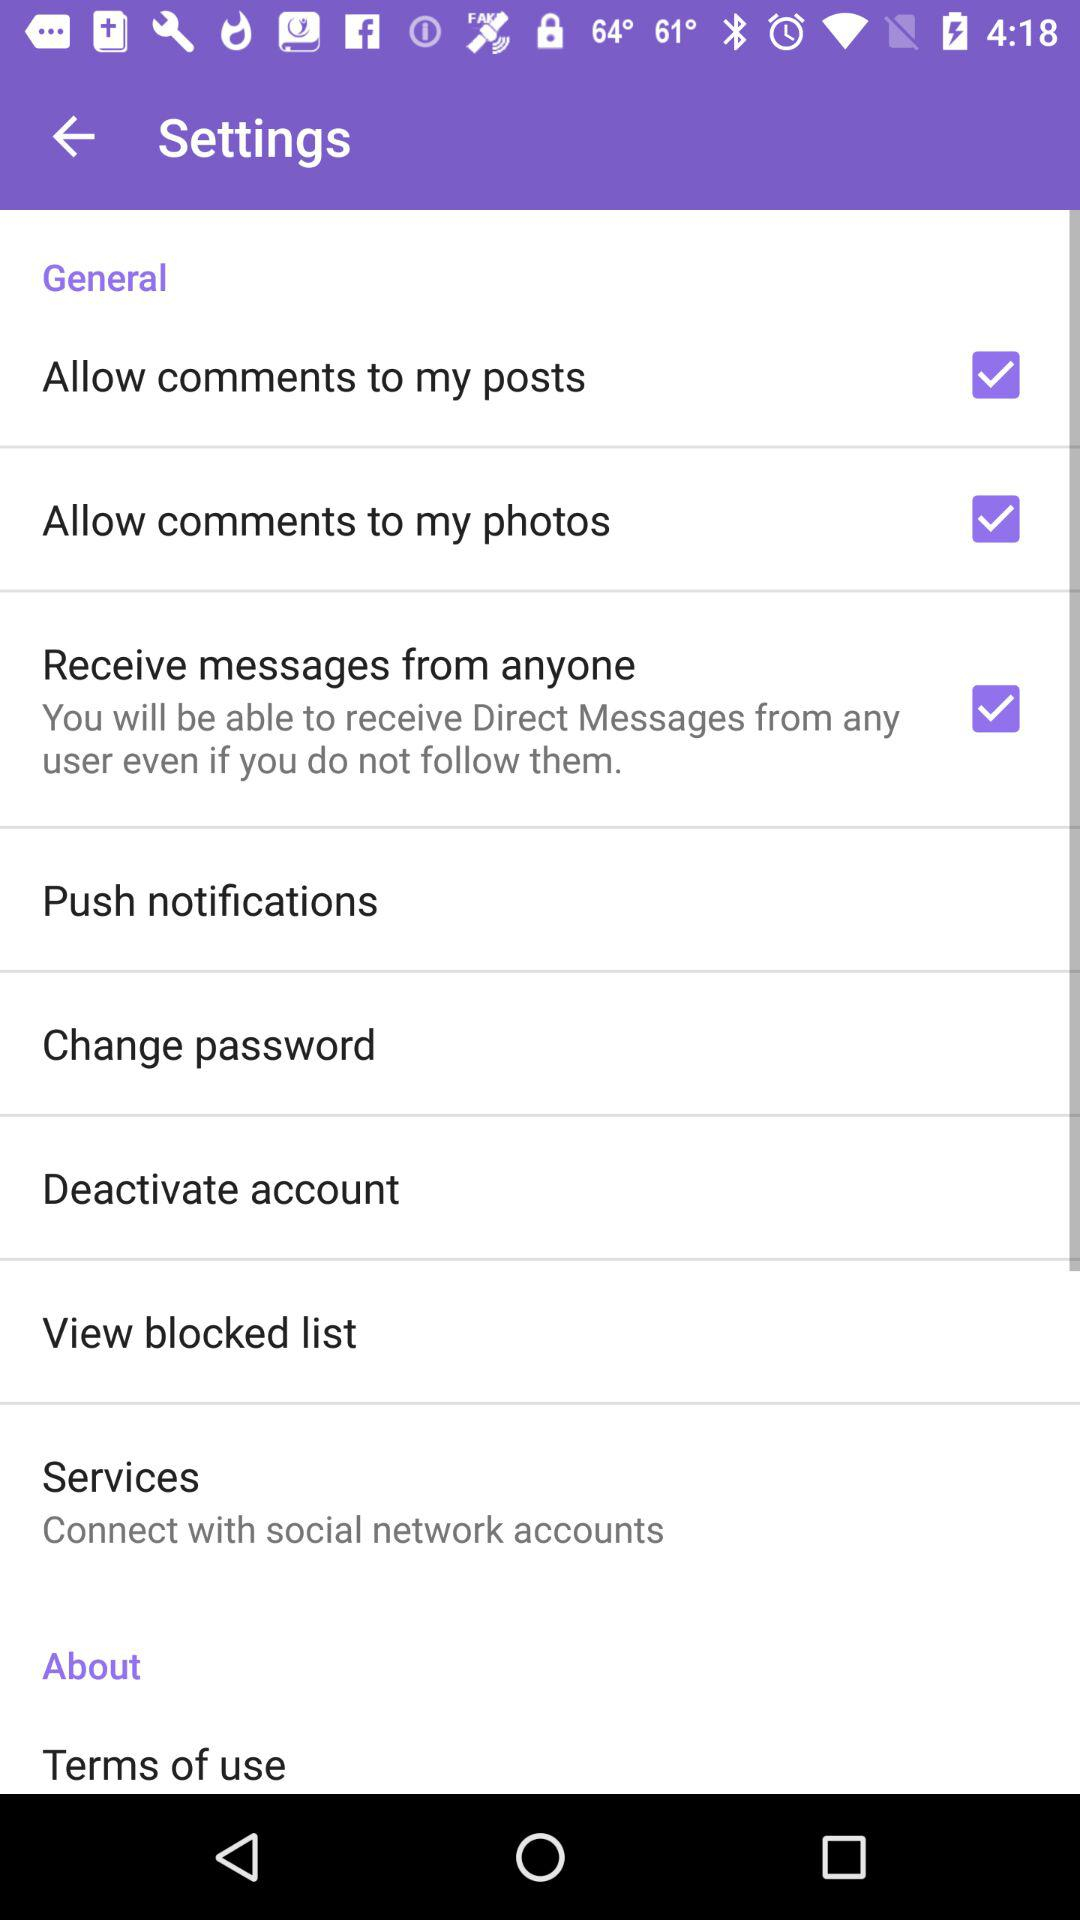What options are checked? The checked options are "Allow comments to my posts", "Allow comments to my photos" and "Receive messages from anyone". 